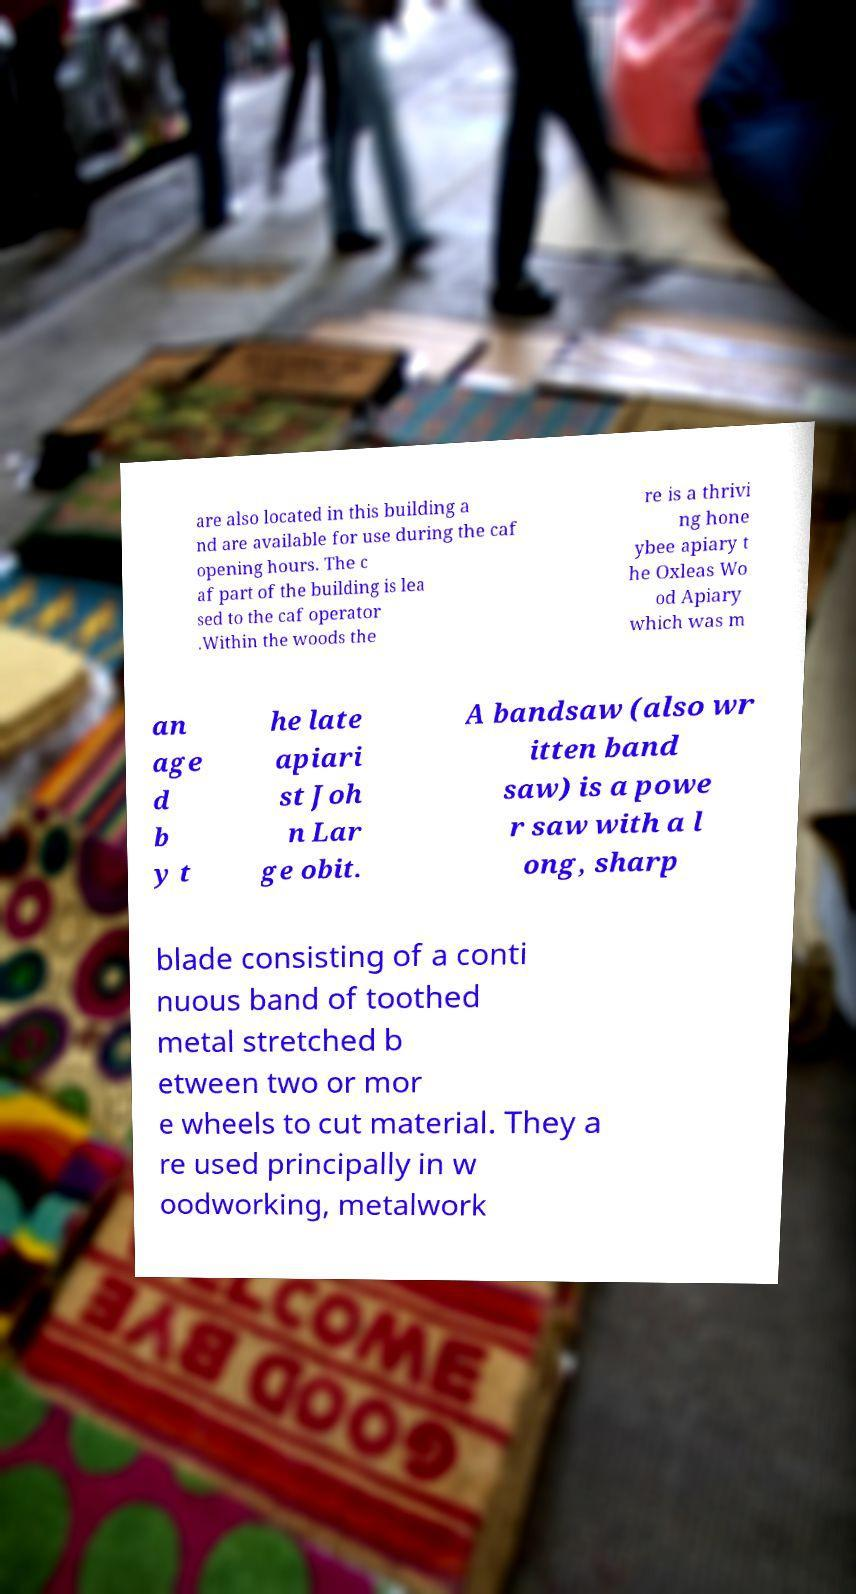I need the written content from this picture converted into text. Can you do that? are also located in this building a nd are available for use during the caf opening hours. The c af part of the building is lea sed to the caf operator .Within the woods the re is a thrivi ng hone ybee apiary t he Oxleas Wo od Apiary which was m an age d b y t he late apiari st Joh n Lar ge obit. A bandsaw (also wr itten band saw) is a powe r saw with a l ong, sharp blade consisting of a conti nuous band of toothed metal stretched b etween two or mor e wheels to cut material. They a re used principally in w oodworking, metalwork 